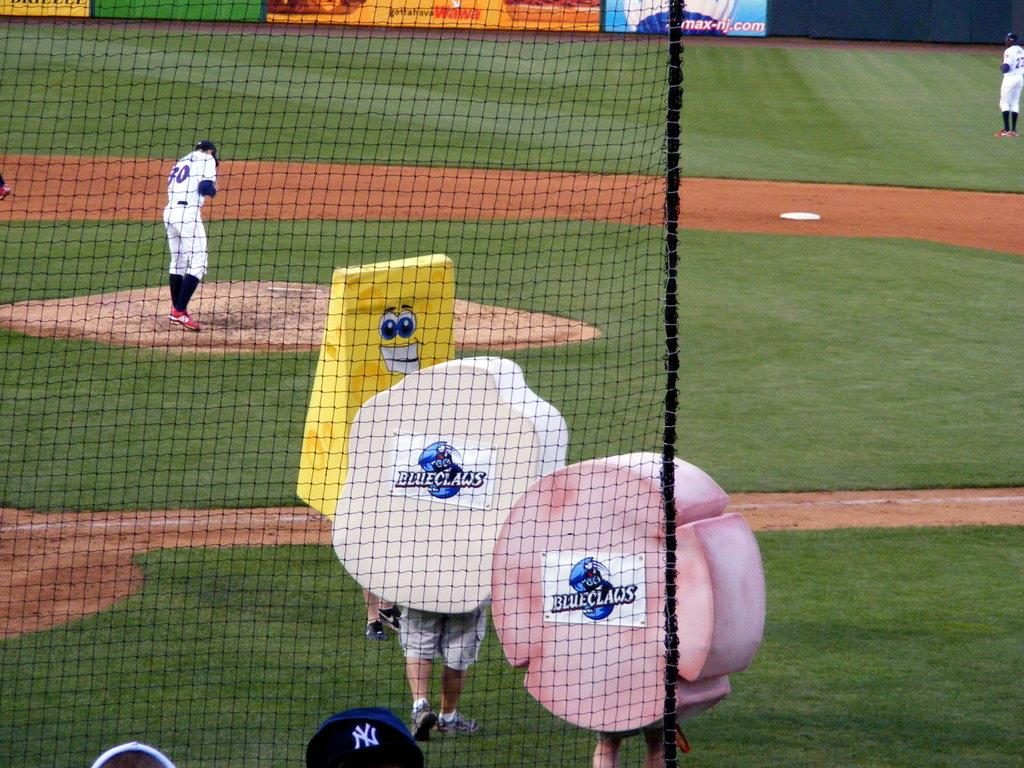<image>
Present a compact description of the photo's key features. Three mascots are on the field and they each have "BlueClaws" on it. 